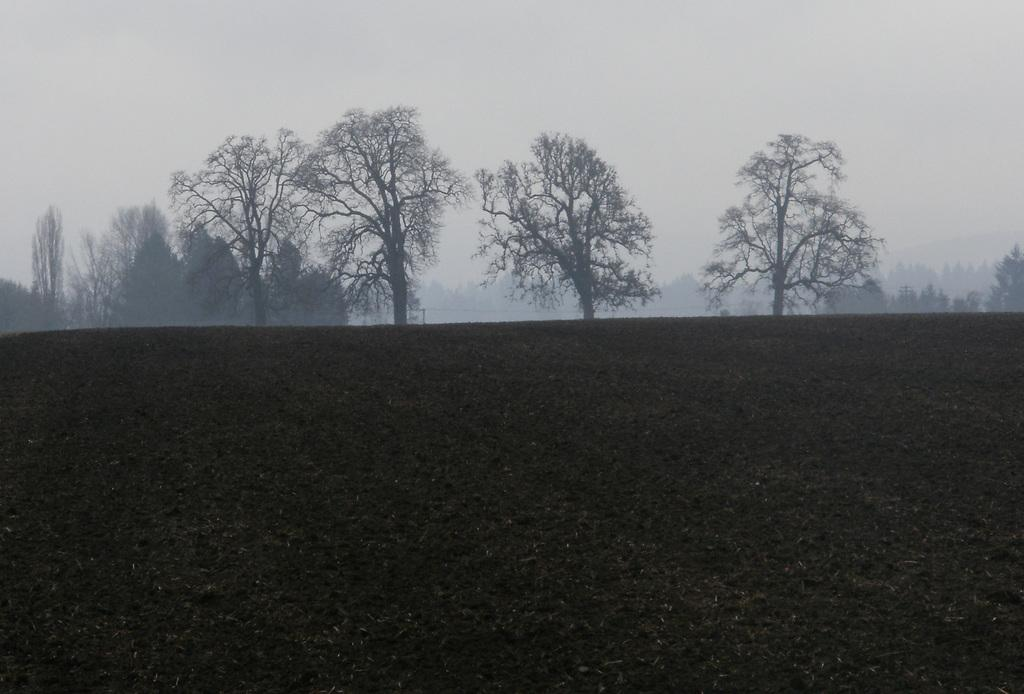What type of vegetation can be seen in the background of the image? There are trees in the background of the image. What is the main feature of the foreground in the image? The foreground of the image is a grassland. What part of the natural environment is visible in the image? The sky is visible in the image. What type of beef is being served at the picnic in the image? There is no picnic or beef present in the image; it features a grassland and trees in the background. How many boys are visible in the image? There are no boys visible in the image. 